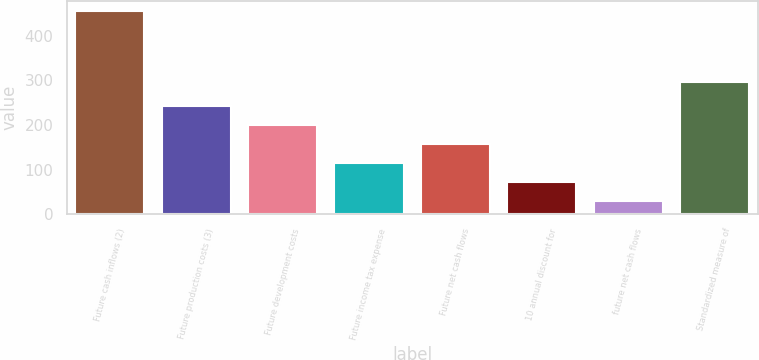<chart> <loc_0><loc_0><loc_500><loc_500><bar_chart><fcel>Future cash inflows (2)<fcel>Future production costs (3)<fcel>Future development costs<fcel>Future income tax expense<fcel>Future net cash flows<fcel>10 annual discount for<fcel>future net cash flows<fcel>Standardized measure of<nl><fcel>455<fcel>242.5<fcel>200<fcel>115<fcel>157.5<fcel>72.5<fcel>30<fcel>296<nl></chart> 